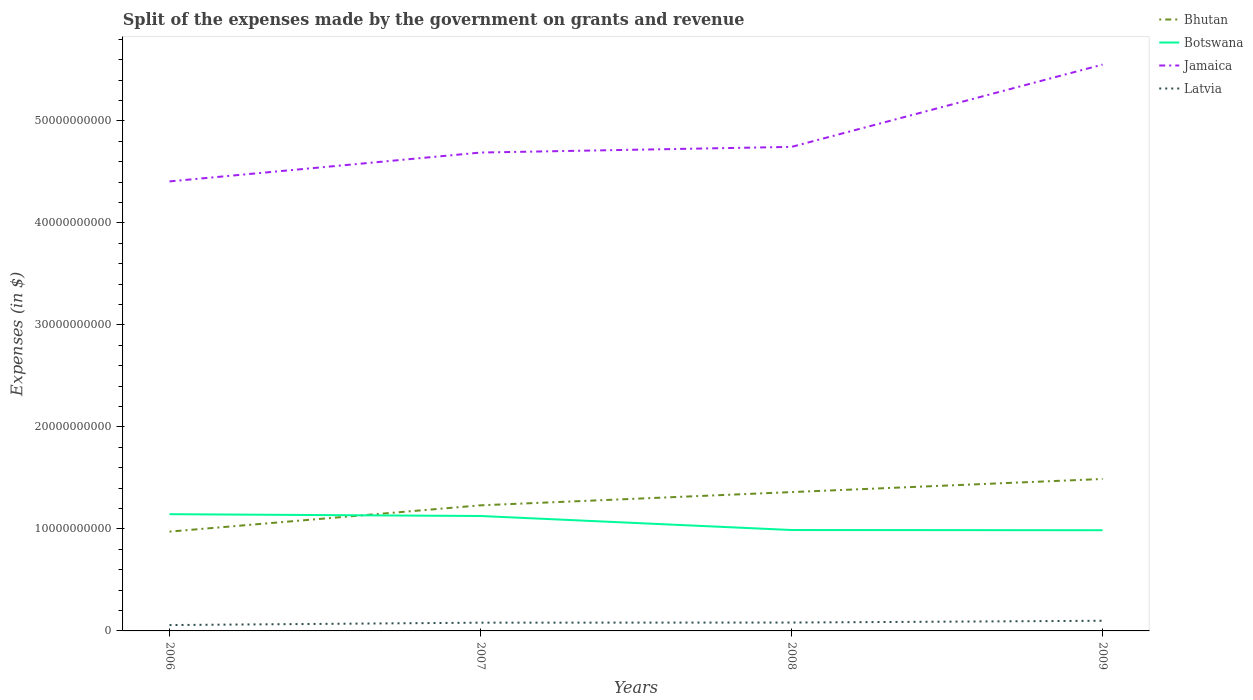Across all years, what is the maximum expenses made by the government on grants and revenue in Botswana?
Keep it short and to the point. 9.87e+09. What is the total expenses made by the government on grants and revenue in Latvia in the graph?
Give a very brief answer. -2.47e+08. What is the difference between the highest and the second highest expenses made by the government on grants and revenue in Jamaica?
Your answer should be compact. 1.15e+1. How many lines are there?
Make the answer very short. 4. How many years are there in the graph?
Offer a terse response. 4. What is the title of the graph?
Make the answer very short. Split of the expenses made by the government on grants and revenue. What is the label or title of the Y-axis?
Keep it short and to the point. Expenses (in $). What is the Expenses (in $) of Bhutan in 2006?
Give a very brief answer. 9.74e+09. What is the Expenses (in $) of Botswana in 2006?
Provide a succinct answer. 1.14e+1. What is the Expenses (in $) of Jamaica in 2006?
Ensure brevity in your answer.  4.41e+1. What is the Expenses (in $) of Latvia in 2006?
Offer a terse response. 5.75e+08. What is the Expenses (in $) of Bhutan in 2007?
Provide a succinct answer. 1.23e+1. What is the Expenses (in $) of Botswana in 2007?
Ensure brevity in your answer.  1.13e+1. What is the Expenses (in $) in Jamaica in 2007?
Your response must be concise. 4.69e+1. What is the Expenses (in $) of Latvia in 2007?
Your answer should be compact. 8.10e+08. What is the Expenses (in $) of Bhutan in 2008?
Give a very brief answer. 1.36e+1. What is the Expenses (in $) of Botswana in 2008?
Your answer should be compact. 9.89e+09. What is the Expenses (in $) in Jamaica in 2008?
Provide a short and direct response. 4.75e+1. What is the Expenses (in $) in Latvia in 2008?
Give a very brief answer. 8.22e+08. What is the Expenses (in $) in Bhutan in 2009?
Offer a very short reply. 1.49e+1. What is the Expenses (in $) in Botswana in 2009?
Provide a short and direct response. 9.87e+09. What is the Expenses (in $) of Jamaica in 2009?
Keep it short and to the point. 5.55e+1. What is the Expenses (in $) in Latvia in 2009?
Provide a succinct answer. 9.95e+08. Across all years, what is the maximum Expenses (in $) of Bhutan?
Provide a short and direct response. 1.49e+1. Across all years, what is the maximum Expenses (in $) in Botswana?
Offer a terse response. 1.14e+1. Across all years, what is the maximum Expenses (in $) in Jamaica?
Your response must be concise. 5.55e+1. Across all years, what is the maximum Expenses (in $) in Latvia?
Offer a terse response. 9.95e+08. Across all years, what is the minimum Expenses (in $) in Bhutan?
Offer a very short reply. 9.74e+09. Across all years, what is the minimum Expenses (in $) of Botswana?
Keep it short and to the point. 9.87e+09. Across all years, what is the minimum Expenses (in $) of Jamaica?
Make the answer very short. 4.41e+1. Across all years, what is the minimum Expenses (in $) of Latvia?
Provide a succinct answer. 5.75e+08. What is the total Expenses (in $) of Bhutan in the graph?
Offer a very short reply. 5.06e+1. What is the total Expenses (in $) in Botswana in the graph?
Keep it short and to the point. 4.25e+1. What is the total Expenses (in $) in Jamaica in the graph?
Offer a very short reply. 1.94e+11. What is the total Expenses (in $) in Latvia in the graph?
Give a very brief answer. 3.20e+09. What is the difference between the Expenses (in $) of Bhutan in 2006 and that in 2007?
Offer a very short reply. -2.58e+09. What is the difference between the Expenses (in $) of Botswana in 2006 and that in 2007?
Make the answer very short. 1.78e+08. What is the difference between the Expenses (in $) of Jamaica in 2006 and that in 2007?
Your response must be concise. -2.83e+09. What is the difference between the Expenses (in $) in Latvia in 2006 and that in 2007?
Offer a terse response. -2.34e+08. What is the difference between the Expenses (in $) of Bhutan in 2006 and that in 2008?
Your answer should be very brief. -3.88e+09. What is the difference between the Expenses (in $) of Botswana in 2006 and that in 2008?
Your response must be concise. 1.55e+09. What is the difference between the Expenses (in $) in Jamaica in 2006 and that in 2008?
Provide a short and direct response. -3.39e+09. What is the difference between the Expenses (in $) of Latvia in 2006 and that in 2008?
Make the answer very short. -2.47e+08. What is the difference between the Expenses (in $) in Bhutan in 2006 and that in 2009?
Your response must be concise. -5.16e+09. What is the difference between the Expenses (in $) in Botswana in 2006 and that in 2009?
Ensure brevity in your answer.  1.57e+09. What is the difference between the Expenses (in $) in Jamaica in 2006 and that in 2009?
Make the answer very short. -1.15e+1. What is the difference between the Expenses (in $) of Latvia in 2006 and that in 2009?
Give a very brief answer. -4.20e+08. What is the difference between the Expenses (in $) in Bhutan in 2007 and that in 2008?
Provide a succinct answer. -1.30e+09. What is the difference between the Expenses (in $) of Botswana in 2007 and that in 2008?
Your response must be concise. 1.37e+09. What is the difference between the Expenses (in $) of Jamaica in 2007 and that in 2008?
Your answer should be very brief. -5.56e+08. What is the difference between the Expenses (in $) in Latvia in 2007 and that in 2008?
Your answer should be compact. -1.25e+07. What is the difference between the Expenses (in $) of Bhutan in 2007 and that in 2009?
Provide a succinct answer. -2.58e+09. What is the difference between the Expenses (in $) of Botswana in 2007 and that in 2009?
Offer a terse response. 1.39e+09. What is the difference between the Expenses (in $) of Jamaica in 2007 and that in 2009?
Offer a terse response. -8.62e+09. What is the difference between the Expenses (in $) of Latvia in 2007 and that in 2009?
Your answer should be very brief. -1.86e+08. What is the difference between the Expenses (in $) of Bhutan in 2008 and that in 2009?
Give a very brief answer. -1.29e+09. What is the difference between the Expenses (in $) of Botswana in 2008 and that in 2009?
Keep it short and to the point. 1.95e+07. What is the difference between the Expenses (in $) of Jamaica in 2008 and that in 2009?
Offer a terse response. -8.07e+09. What is the difference between the Expenses (in $) in Latvia in 2008 and that in 2009?
Offer a very short reply. -1.73e+08. What is the difference between the Expenses (in $) of Bhutan in 2006 and the Expenses (in $) of Botswana in 2007?
Give a very brief answer. -1.53e+09. What is the difference between the Expenses (in $) of Bhutan in 2006 and the Expenses (in $) of Jamaica in 2007?
Your answer should be compact. -3.72e+1. What is the difference between the Expenses (in $) of Bhutan in 2006 and the Expenses (in $) of Latvia in 2007?
Your answer should be very brief. 8.93e+09. What is the difference between the Expenses (in $) of Botswana in 2006 and the Expenses (in $) of Jamaica in 2007?
Ensure brevity in your answer.  -3.55e+1. What is the difference between the Expenses (in $) of Botswana in 2006 and the Expenses (in $) of Latvia in 2007?
Your answer should be compact. 1.06e+1. What is the difference between the Expenses (in $) in Jamaica in 2006 and the Expenses (in $) in Latvia in 2007?
Offer a very short reply. 4.33e+1. What is the difference between the Expenses (in $) in Bhutan in 2006 and the Expenses (in $) in Botswana in 2008?
Make the answer very short. -1.57e+08. What is the difference between the Expenses (in $) of Bhutan in 2006 and the Expenses (in $) of Jamaica in 2008?
Give a very brief answer. -3.77e+1. What is the difference between the Expenses (in $) in Bhutan in 2006 and the Expenses (in $) in Latvia in 2008?
Ensure brevity in your answer.  8.92e+09. What is the difference between the Expenses (in $) in Botswana in 2006 and the Expenses (in $) in Jamaica in 2008?
Keep it short and to the point. -3.60e+1. What is the difference between the Expenses (in $) of Botswana in 2006 and the Expenses (in $) of Latvia in 2008?
Your response must be concise. 1.06e+1. What is the difference between the Expenses (in $) of Jamaica in 2006 and the Expenses (in $) of Latvia in 2008?
Offer a very short reply. 4.33e+1. What is the difference between the Expenses (in $) in Bhutan in 2006 and the Expenses (in $) in Botswana in 2009?
Offer a terse response. -1.37e+08. What is the difference between the Expenses (in $) of Bhutan in 2006 and the Expenses (in $) of Jamaica in 2009?
Your answer should be compact. -4.58e+1. What is the difference between the Expenses (in $) of Bhutan in 2006 and the Expenses (in $) of Latvia in 2009?
Your answer should be very brief. 8.74e+09. What is the difference between the Expenses (in $) of Botswana in 2006 and the Expenses (in $) of Jamaica in 2009?
Offer a very short reply. -4.41e+1. What is the difference between the Expenses (in $) of Botswana in 2006 and the Expenses (in $) of Latvia in 2009?
Your response must be concise. 1.05e+1. What is the difference between the Expenses (in $) of Jamaica in 2006 and the Expenses (in $) of Latvia in 2009?
Keep it short and to the point. 4.31e+1. What is the difference between the Expenses (in $) in Bhutan in 2007 and the Expenses (in $) in Botswana in 2008?
Offer a very short reply. 2.42e+09. What is the difference between the Expenses (in $) of Bhutan in 2007 and the Expenses (in $) of Jamaica in 2008?
Provide a short and direct response. -3.51e+1. What is the difference between the Expenses (in $) in Bhutan in 2007 and the Expenses (in $) in Latvia in 2008?
Keep it short and to the point. 1.15e+1. What is the difference between the Expenses (in $) of Botswana in 2007 and the Expenses (in $) of Jamaica in 2008?
Offer a very short reply. -3.62e+1. What is the difference between the Expenses (in $) in Botswana in 2007 and the Expenses (in $) in Latvia in 2008?
Give a very brief answer. 1.04e+1. What is the difference between the Expenses (in $) of Jamaica in 2007 and the Expenses (in $) of Latvia in 2008?
Offer a very short reply. 4.61e+1. What is the difference between the Expenses (in $) of Bhutan in 2007 and the Expenses (in $) of Botswana in 2009?
Your answer should be very brief. 2.44e+09. What is the difference between the Expenses (in $) of Bhutan in 2007 and the Expenses (in $) of Jamaica in 2009?
Offer a terse response. -4.32e+1. What is the difference between the Expenses (in $) in Bhutan in 2007 and the Expenses (in $) in Latvia in 2009?
Your answer should be very brief. 1.13e+1. What is the difference between the Expenses (in $) of Botswana in 2007 and the Expenses (in $) of Jamaica in 2009?
Your response must be concise. -4.43e+1. What is the difference between the Expenses (in $) in Botswana in 2007 and the Expenses (in $) in Latvia in 2009?
Your answer should be compact. 1.03e+1. What is the difference between the Expenses (in $) of Jamaica in 2007 and the Expenses (in $) of Latvia in 2009?
Your answer should be very brief. 4.59e+1. What is the difference between the Expenses (in $) in Bhutan in 2008 and the Expenses (in $) in Botswana in 2009?
Make the answer very short. 3.74e+09. What is the difference between the Expenses (in $) of Bhutan in 2008 and the Expenses (in $) of Jamaica in 2009?
Make the answer very short. -4.19e+1. What is the difference between the Expenses (in $) in Bhutan in 2008 and the Expenses (in $) in Latvia in 2009?
Offer a very short reply. 1.26e+1. What is the difference between the Expenses (in $) in Botswana in 2008 and the Expenses (in $) in Jamaica in 2009?
Your response must be concise. -4.56e+1. What is the difference between the Expenses (in $) in Botswana in 2008 and the Expenses (in $) in Latvia in 2009?
Provide a short and direct response. 8.90e+09. What is the difference between the Expenses (in $) in Jamaica in 2008 and the Expenses (in $) in Latvia in 2009?
Your response must be concise. 4.65e+1. What is the average Expenses (in $) in Bhutan per year?
Your response must be concise. 1.26e+1. What is the average Expenses (in $) of Botswana per year?
Provide a succinct answer. 1.06e+1. What is the average Expenses (in $) in Jamaica per year?
Provide a short and direct response. 4.85e+1. What is the average Expenses (in $) of Latvia per year?
Your response must be concise. 8.01e+08. In the year 2006, what is the difference between the Expenses (in $) in Bhutan and Expenses (in $) in Botswana?
Offer a very short reply. -1.71e+09. In the year 2006, what is the difference between the Expenses (in $) of Bhutan and Expenses (in $) of Jamaica?
Offer a terse response. -3.43e+1. In the year 2006, what is the difference between the Expenses (in $) in Bhutan and Expenses (in $) in Latvia?
Your response must be concise. 9.16e+09. In the year 2006, what is the difference between the Expenses (in $) in Botswana and Expenses (in $) in Jamaica?
Your answer should be very brief. -3.26e+1. In the year 2006, what is the difference between the Expenses (in $) in Botswana and Expenses (in $) in Latvia?
Your response must be concise. 1.09e+1. In the year 2006, what is the difference between the Expenses (in $) in Jamaica and Expenses (in $) in Latvia?
Offer a terse response. 4.35e+1. In the year 2007, what is the difference between the Expenses (in $) of Bhutan and Expenses (in $) of Botswana?
Your answer should be very brief. 1.05e+09. In the year 2007, what is the difference between the Expenses (in $) of Bhutan and Expenses (in $) of Jamaica?
Your response must be concise. -3.46e+1. In the year 2007, what is the difference between the Expenses (in $) of Bhutan and Expenses (in $) of Latvia?
Offer a very short reply. 1.15e+1. In the year 2007, what is the difference between the Expenses (in $) of Botswana and Expenses (in $) of Jamaica?
Your answer should be compact. -3.56e+1. In the year 2007, what is the difference between the Expenses (in $) of Botswana and Expenses (in $) of Latvia?
Give a very brief answer. 1.05e+1. In the year 2007, what is the difference between the Expenses (in $) in Jamaica and Expenses (in $) in Latvia?
Offer a terse response. 4.61e+1. In the year 2008, what is the difference between the Expenses (in $) of Bhutan and Expenses (in $) of Botswana?
Give a very brief answer. 3.72e+09. In the year 2008, what is the difference between the Expenses (in $) in Bhutan and Expenses (in $) in Jamaica?
Make the answer very short. -3.38e+1. In the year 2008, what is the difference between the Expenses (in $) of Bhutan and Expenses (in $) of Latvia?
Provide a short and direct response. 1.28e+1. In the year 2008, what is the difference between the Expenses (in $) of Botswana and Expenses (in $) of Jamaica?
Offer a terse response. -3.76e+1. In the year 2008, what is the difference between the Expenses (in $) in Botswana and Expenses (in $) in Latvia?
Provide a short and direct response. 9.07e+09. In the year 2008, what is the difference between the Expenses (in $) in Jamaica and Expenses (in $) in Latvia?
Provide a short and direct response. 4.66e+1. In the year 2009, what is the difference between the Expenses (in $) of Bhutan and Expenses (in $) of Botswana?
Provide a short and direct response. 5.02e+09. In the year 2009, what is the difference between the Expenses (in $) in Bhutan and Expenses (in $) in Jamaica?
Your answer should be compact. -4.06e+1. In the year 2009, what is the difference between the Expenses (in $) in Bhutan and Expenses (in $) in Latvia?
Make the answer very short. 1.39e+1. In the year 2009, what is the difference between the Expenses (in $) of Botswana and Expenses (in $) of Jamaica?
Your response must be concise. -4.57e+1. In the year 2009, what is the difference between the Expenses (in $) of Botswana and Expenses (in $) of Latvia?
Offer a very short reply. 8.88e+09. In the year 2009, what is the difference between the Expenses (in $) in Jamaica and Expenses (in $) in Latvia?
Provide a succinct answer. 5.45e+1. What is the ratio of the Expenses (in $) in Bhutan in 2006 to that in 2007?
Offer a terse response. 0.79. What is the ratio of the Expenses (in $) of Botswana in 2006 to that in 2007?
Make the answer very short. 1.02. What is the ratio of the Expenses (in $) in Jamaica in 2006 to that in 2007?
Provide a short and direct response. 0.94. What is the ratio of the Expenses (in $) of Latvia in 2006 to that in 2007?
Keep it short and to the point. 0.71. What is the ratio of the Expenses (in $) of Bhutan in 2006 to that in 2008?
Provide a short and direct response. 0.72. What is the ratio of the Expenses (in $) of Botswana in 2006 to that in 2008?
Provide a short and direct response. 1.16. What is the ratio of the Expenses (in $) in Jamaica in 2006 to that in 2008?
Your response must be concise. 0.93. What is the ratio of the Expenses (in $) in Latvia in 2006 to that in 2008?
Offer a terse response. 0.7. What is the ratio of the Expenses (in $) of Bhutan in 2006 to that in 2009?
Your answer should be very brief. 0.65. What is the ratio of the Expenses (in $) of Botswana in 2006 to that in 2009?
Make the answer very short. 1.16. What is the ratio of the Expenses (in $) in Jamaica in 2006 to that in 2009?
Your answer should be compact. 0.79. What is the ratio of the Expenses (in $) in Latvia in 2006 to that in 2009?
Give a very brief answer. 0.58. What is the ratio of the Expenses (in $) in Bhutan in 2007 to that in 2008?
Make the answer very short. 0.9. What is the ratio of the Expenses (in $) of Botswana in 2007 to that in 2008?
Ensure brevity in your answer.  1.14. What is the ratio of the Expenses (in $) of Jamaica in 2007 to that in 2008?
Your response must be concise. 0.99. What is the ratio of the Expenses (in $) of Latvia in 2007 to that in 2008?
Your response must be concise. 0.98. What is the ratio of the Expenses (in $) in Bhutan in 2007 to that in 2009?
Your answer should be compact. 0.83. What is the ratio of the Expenses (in $) in Botswana in 2007 to that in 2009?
Keep it short and to the point. 1.14. What is the ratio of the Expenses (in $) in Jamaica in 2007 to that in 2009?
Your response must be concise. 0.84. What is the ratio of the Expenses (in $) in Latvia in 2007 to that in 2009?
Your answer should be compact. 0.81. What is the ratio of the Expenses (in $) in Bhutan in 2008 to that in 2009?
Make the answer very short. 0.91. What is the ratio of the Expenses (in $) in Jamaica in 2008 to that in 2009?
Offer a terse response. 0.85. What is the ratio of the Expenses (in $) of Latvia in 2008 to that in 2009?
Offer a terse response. 0.83. What is the difference between the highest and the second highest Expenses (in $) of Bhutan?
Give a very brief answer. 1.29e+09. What is the difference between the highest and the second highest Expenses (in $) in Botswana?
Your answer should be compact. 1.78e+08. What is the difference between the highest and the second highest Expenses (in $) of Jamaica?
Offer a very short reply. 8.07e+09. What is the difference between the highest and the second highest Expenses (in $) in Latvia?
Provide a short and direct response. 1.73e+08. What is the difference between the highest and the lowest Expenses (in $) in Bhutan?
Offer a terse response. 5.16e+09. What is the difference between the highest and the lowest Expenses (in $) in Botswana?
Provide a short and direct response. 1.57e+09. What is the difference between the highest and the lowest Expenses (in $) in Jamaica?
Ensure brevity in your answer.  1.15e+1. What is the difference between the highest and the lowest Expenses (in $) of Latvia?
Provide a succinct answer. 4.20e+08. 